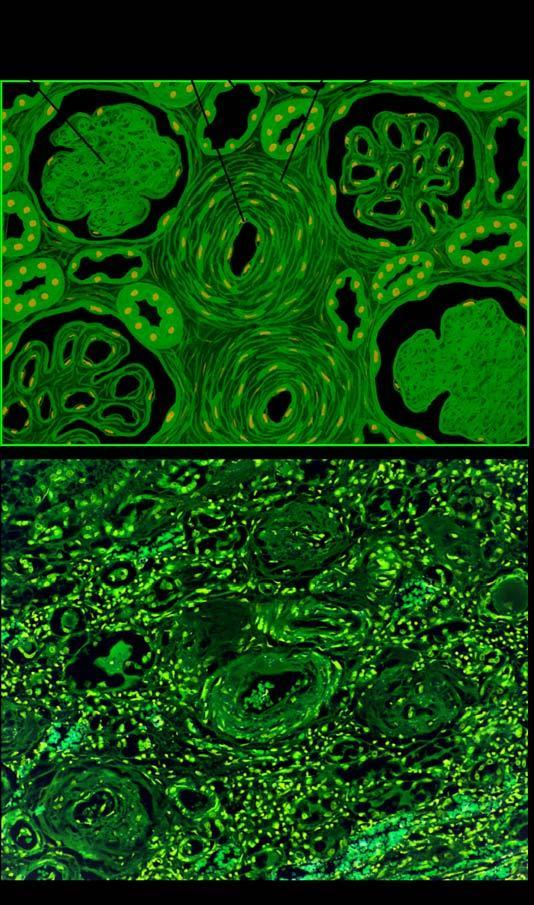what are hyaline arteriolosclerosis and intimal thickening of small blood vessels in the glomerular tuft?
Answer the question using a single word or phrase. Vascular changes 